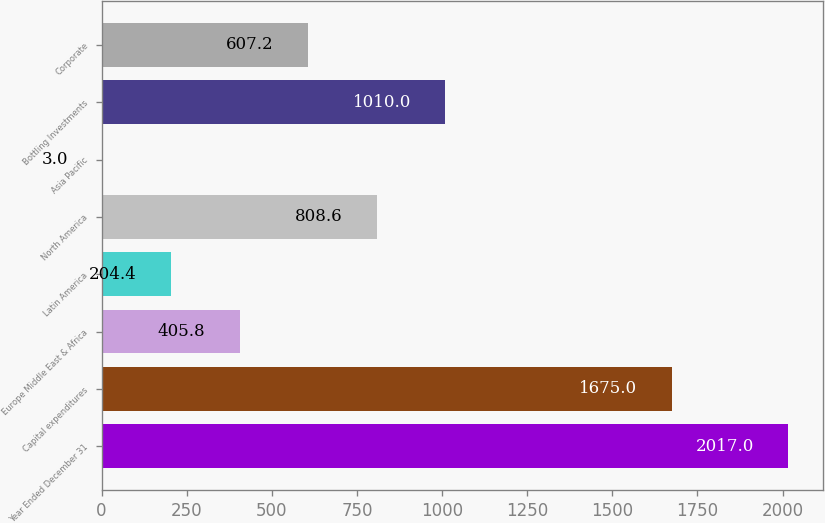Convert chart. <chart><loc_0><loc_0><loc_500><loc_500><bar_chart><fcel>Year Ended December 31<fcel>Capital expenditures<fcel>Europe Middle East & Africa<fcel>Latin America<fcel>North America<fcel>Asia Pacific<fcel>Bottling Investments<fcel>Corporate<nl><fcel>2017<fcel>1675<fcel>405.8<fcel>204.4<fcel>808.6<fcel>3<fcel>1010<fcel>607.2<nl></chart> 